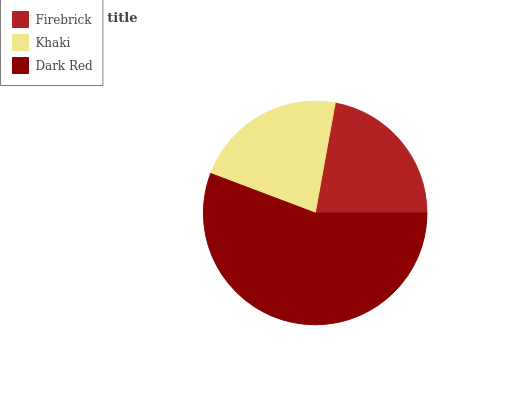Is Khaki the minimum?
Answer yes or no. Yes. Is Dark Red the maximum?
Answer yes or no. Yes. Is Dark Red the minimum?
Answer yes or no. No. Is Khaki the maximum?
Answer yes or no. No. Is Dark Red greater than Khaki?
Answer yes or no. Yes. Is Khaki less than Dark Red?
Answer yes or no. Yes. Is Khaki greater than Dark Red?
Answer yes or no. No. Is Dark Red less than Khaki?
Answer yes or no. No. Is Firebrick the high median?
Answer yes or no. Yes. Is Firebrick the low median?
Answer yes or no. Yes. Is Khaki the high median?
Answer yes or no. No. Is Dark Red the low median?
Answer yes or no. No. 